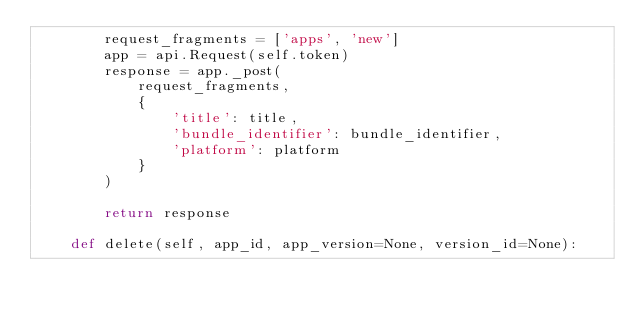Convert code to text. <code><loc_0><loc_0><loc_500><loc_500><_Python_>        request_fragments = ['apps', 'new']
        app = api.Request(self.token)
        response = app._post(
            request_fragments,
            {
                'title': title, 
                'bundle_identifier': bundle_identifier,
                'platform': platform
            }
        )

        return response

    def delete(self, app_id, app_version=None, version_id=None):</code> 